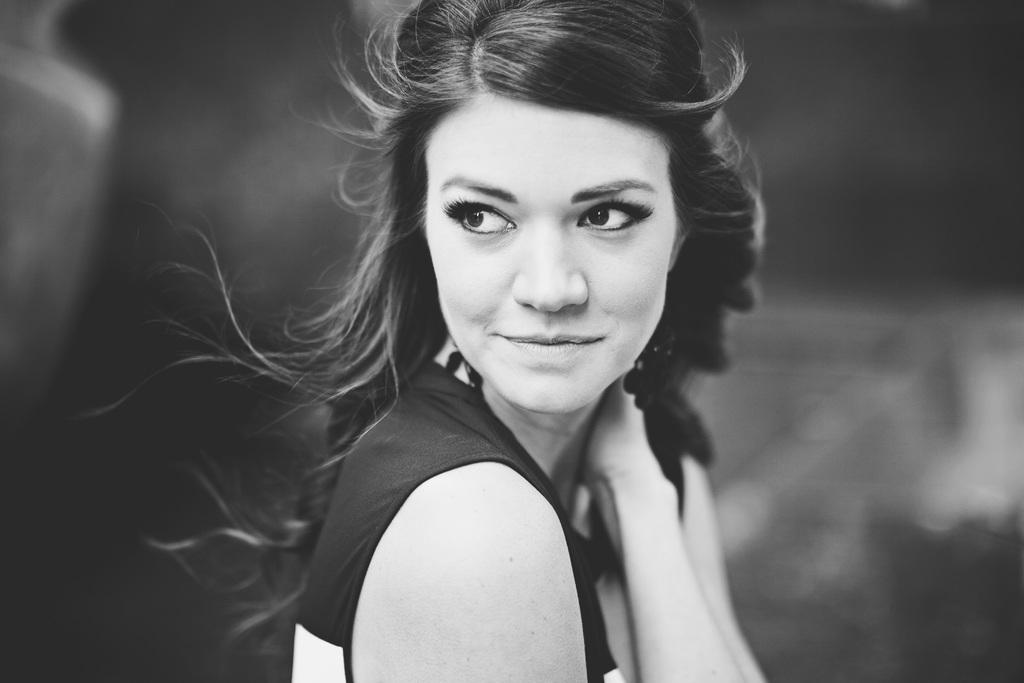Who is present in the image? There is a woman in the image. What is the woman wearing? The woman is wearing a t-shirt. What is the woman's facial expression? The woman is smiling. Can you describe the background of the image? The background of the image is blurred. Can you see any tigers with fangs in the image? There are no tigers or fangs present in the image. 